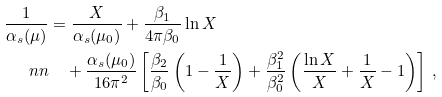Convert formula to latex. <formula><loc_0><loc_0><loc_500><loc_500>\frac { 1 } { \alpha _ { s } ( \mu ) } & = \frac { X } { \alpha _ { s } ( \mu _ { 0 } ) } + \frac { \beta _ { 1 } } { 4 \pi \beta _ { 0 } } \ln X \\ \ n n & \quad + \frac { \alpha _ { s } ( \mu _ { 0 } ) } { 1 6 \pi ^ { 2 } } \left [ \frac { \beta _ { 2 } } { \beta _ { 0 } } \left ( 1 - \frac { 1 } { X } \right ) + \frac { \beta _ { 1 } ^ { 2 } } { \beta _ { 0 } ^ { 2 } } \left ( \frac { \ln X } { X } + \frac { 1 } { X } - 1 \right ) \right ] \, ,</formula> 